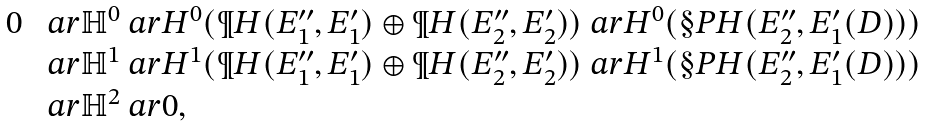<formula> <loc_0><loc_0><loc_500><loc_500>\begin{array} { l l } 0 & \ a r \mathbb { H } ^ { 0 } \ a r H ^ { 0 } ( \P H ( E _ { 1 } ^ { \prime \prime } , E _ { 1 } ^ { \prime } ) \oplus \P H ( E _ { 2 } ^ { \prime \prime } , E _ { 2 } ^ { \prime } ) ) \ a r H ^ { 0 } ( \S P H ( E _ { 2 } ^ { \prime \prime } , E _ { 1 } ^ { \prime } ( D ) ) ) \\ & \ a r \mathbb { H } ^ { 1 } \ a r H ^ { 1 } ( \P H ( E _ { 1 } ^ { \prime \prime } , E _ { 1 } ^ { \prime } ) \oplus \P H ( E _ { 2 } ^ { \prime \prime } , E _ { 2 } ^ { \prime } ) ) \ a r H ^ { 1 } ( \S P H ( E _ { 2 } ^ { \prime \prime } , E _ { 1 } ^ { \prime } ( D ) ) ) \\ & \ a r \mathbb { H } ^ { 2 } \ a r 0 , \end{array}</formula> 